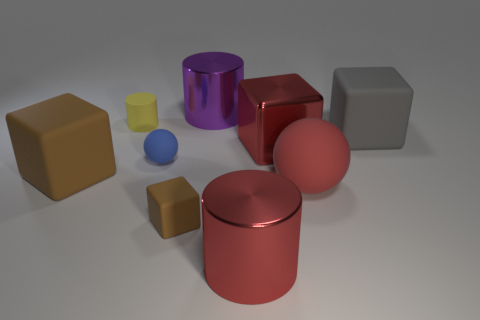Is the number of tiny cubes behind the red ball the same as the number of gray cubes in front of the large gray cube?
Provide a succinct answer. Yes. There is a small matte thing that is in front of the large red rubber object; is there a large rubber sphere in front of it?
Your answer should be very brief. No. The yellow matte thing has what shape?
Make the answer very short. Cylinder. What is the size of the metal cube that is the same color as the big ball?
Offer a very short reply. Large. There is a matte cube on the right side of the cylinder that is in front of the tiny rubber cylinder; what size is it?
Offer a very short reply. Large. What is the size of the shiny cylinder that is in front of the red block?
Your answer should be compact. Large. Are there fewer small spheres that are to the left of the small blue rubber ball than large spheres behind the big red matte object?
Ensure brevity in your answer.  No. What color is the large metallic block?
Offer a very short reply. Red. Is there a large thing of the same color as the small matte cube?
Provide a succinct answer. Yes. There is a big rubber object that is on the left side of the large cylinder behind the red block that is right of the purple metallic cylinder; what is its shape?
Your answer should be very brief. Cube. 